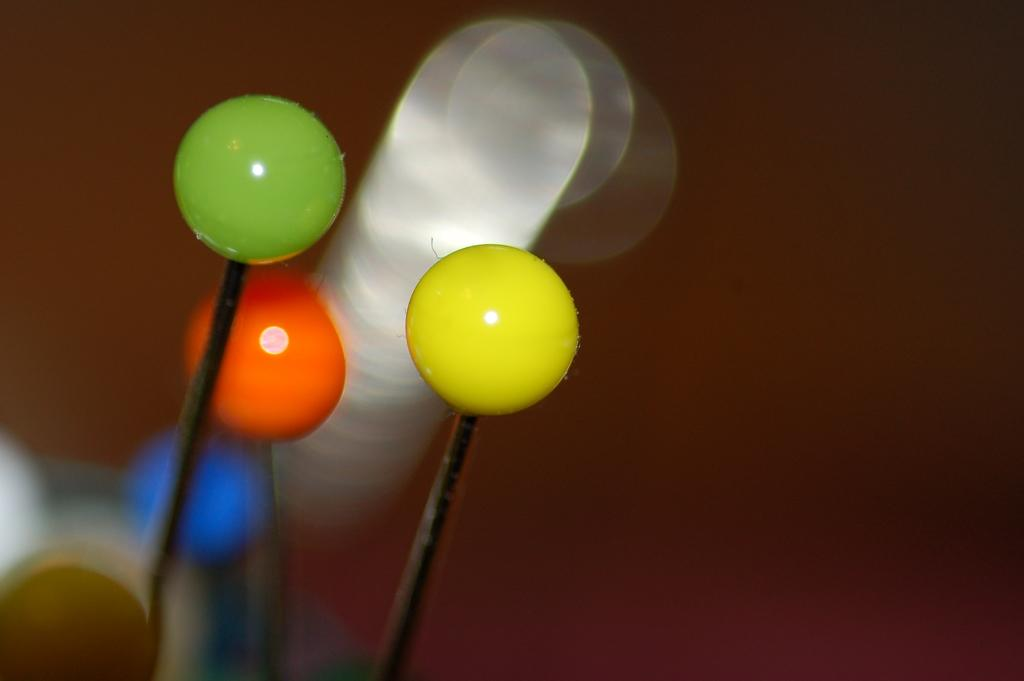What shape are the objects in the image? The objects in the image are round. How are the round objects connected to another object? The round objects are attached to a black object. What can be seen in the background of the image? There are other objects in the background of the image. What grade of lumber is being used to construct the ground in the image? There is no lumber or ground present in the image; it features round objects attached to a black object with other objects in the background. 